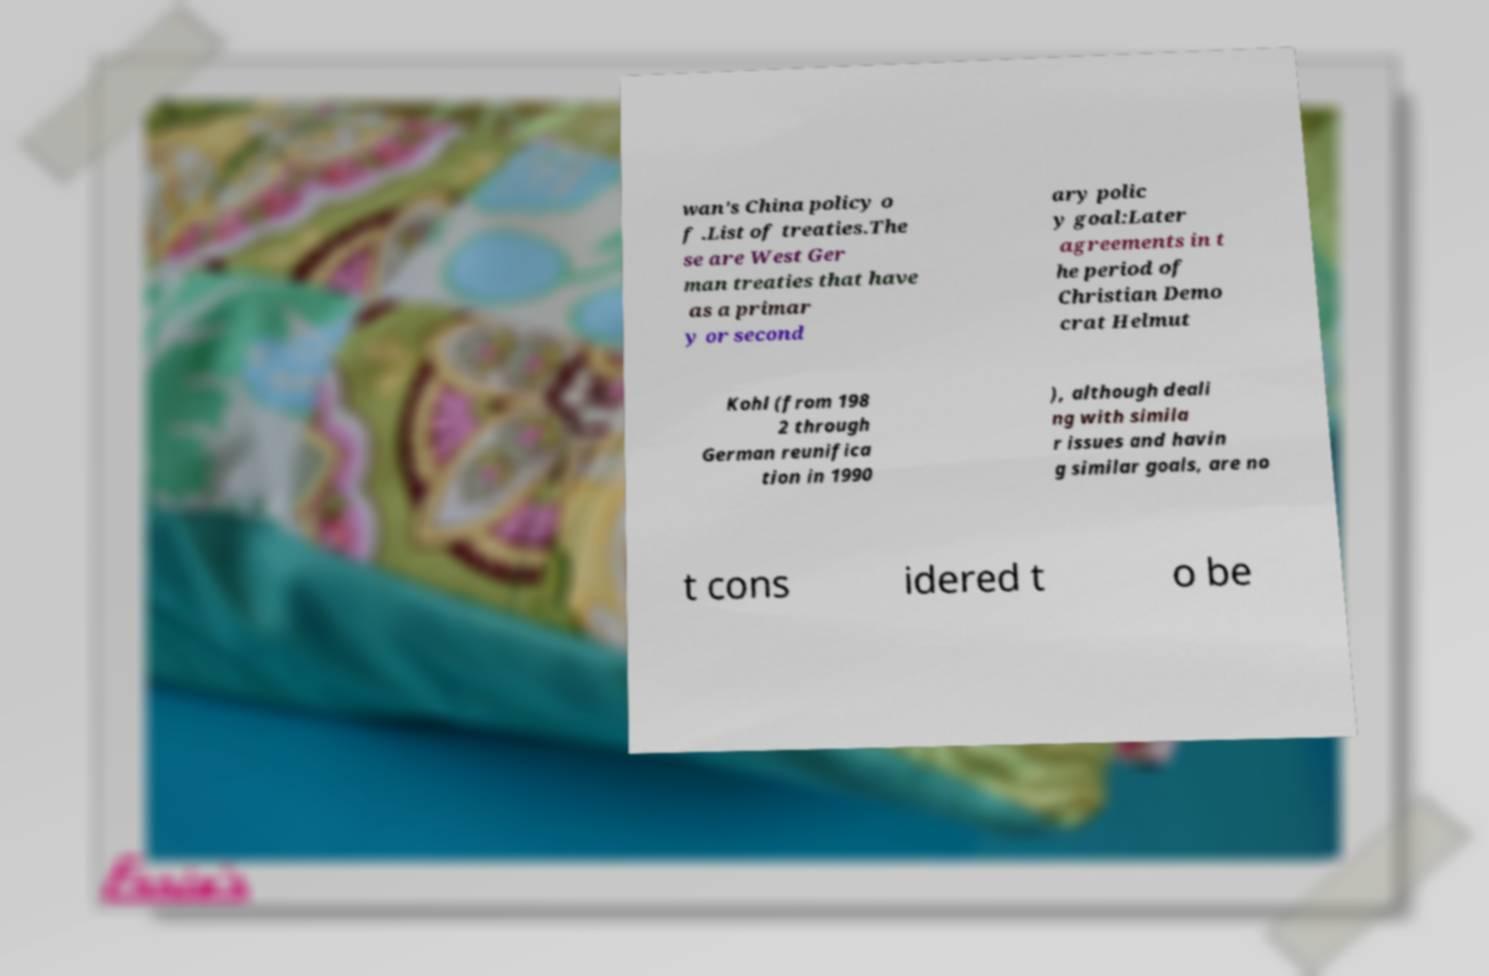Please read and relay the text visible in this image. What does it say? wan's China policy o f .List of treaties.The se are West Ger man treaties that have as a primar y or second ary polic y goal:Later agreements in t he period of Christian Demo crat Helmut Kohl (from 198 2 through German reunifica tion in 1990 ), although deali ng with simila r issues and havin g similar goals, are no t cons idered t o be 